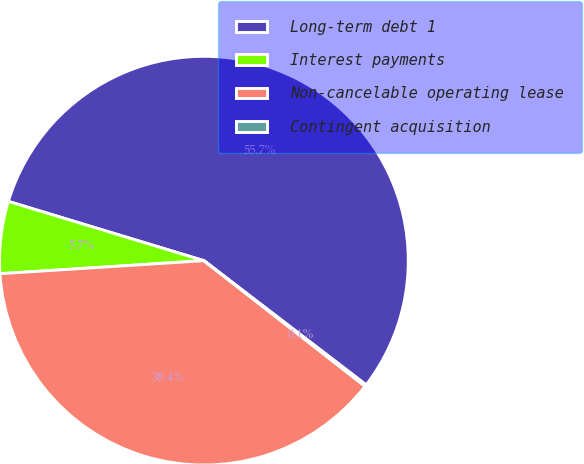Convert chart to OTSL. <chart><loc_0><loc_0><loc_500><loc_500><pie_chart><fcel>Long-term debt 1<fcel>Interest payments<fcel>Non-cancelable operating lease<fcel>Contingent acquisition<nl><fcel>55.72%<fcel>5.7%<fcel>38.45%<fcel>0.14%<nl></chart> 